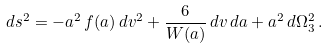<formula> <loc_0><loc_0><loc_500><loc_500>d s ^ { 2 } = - a ^ { 2 } \, f ( a ) \, d v ^ { 2 } + \frac { 6 } { W ( a ) } \, d v \, d a + a ^ { 2 } \, d \Omega _ { 3 } ^ { 2 } \, .</formula> 